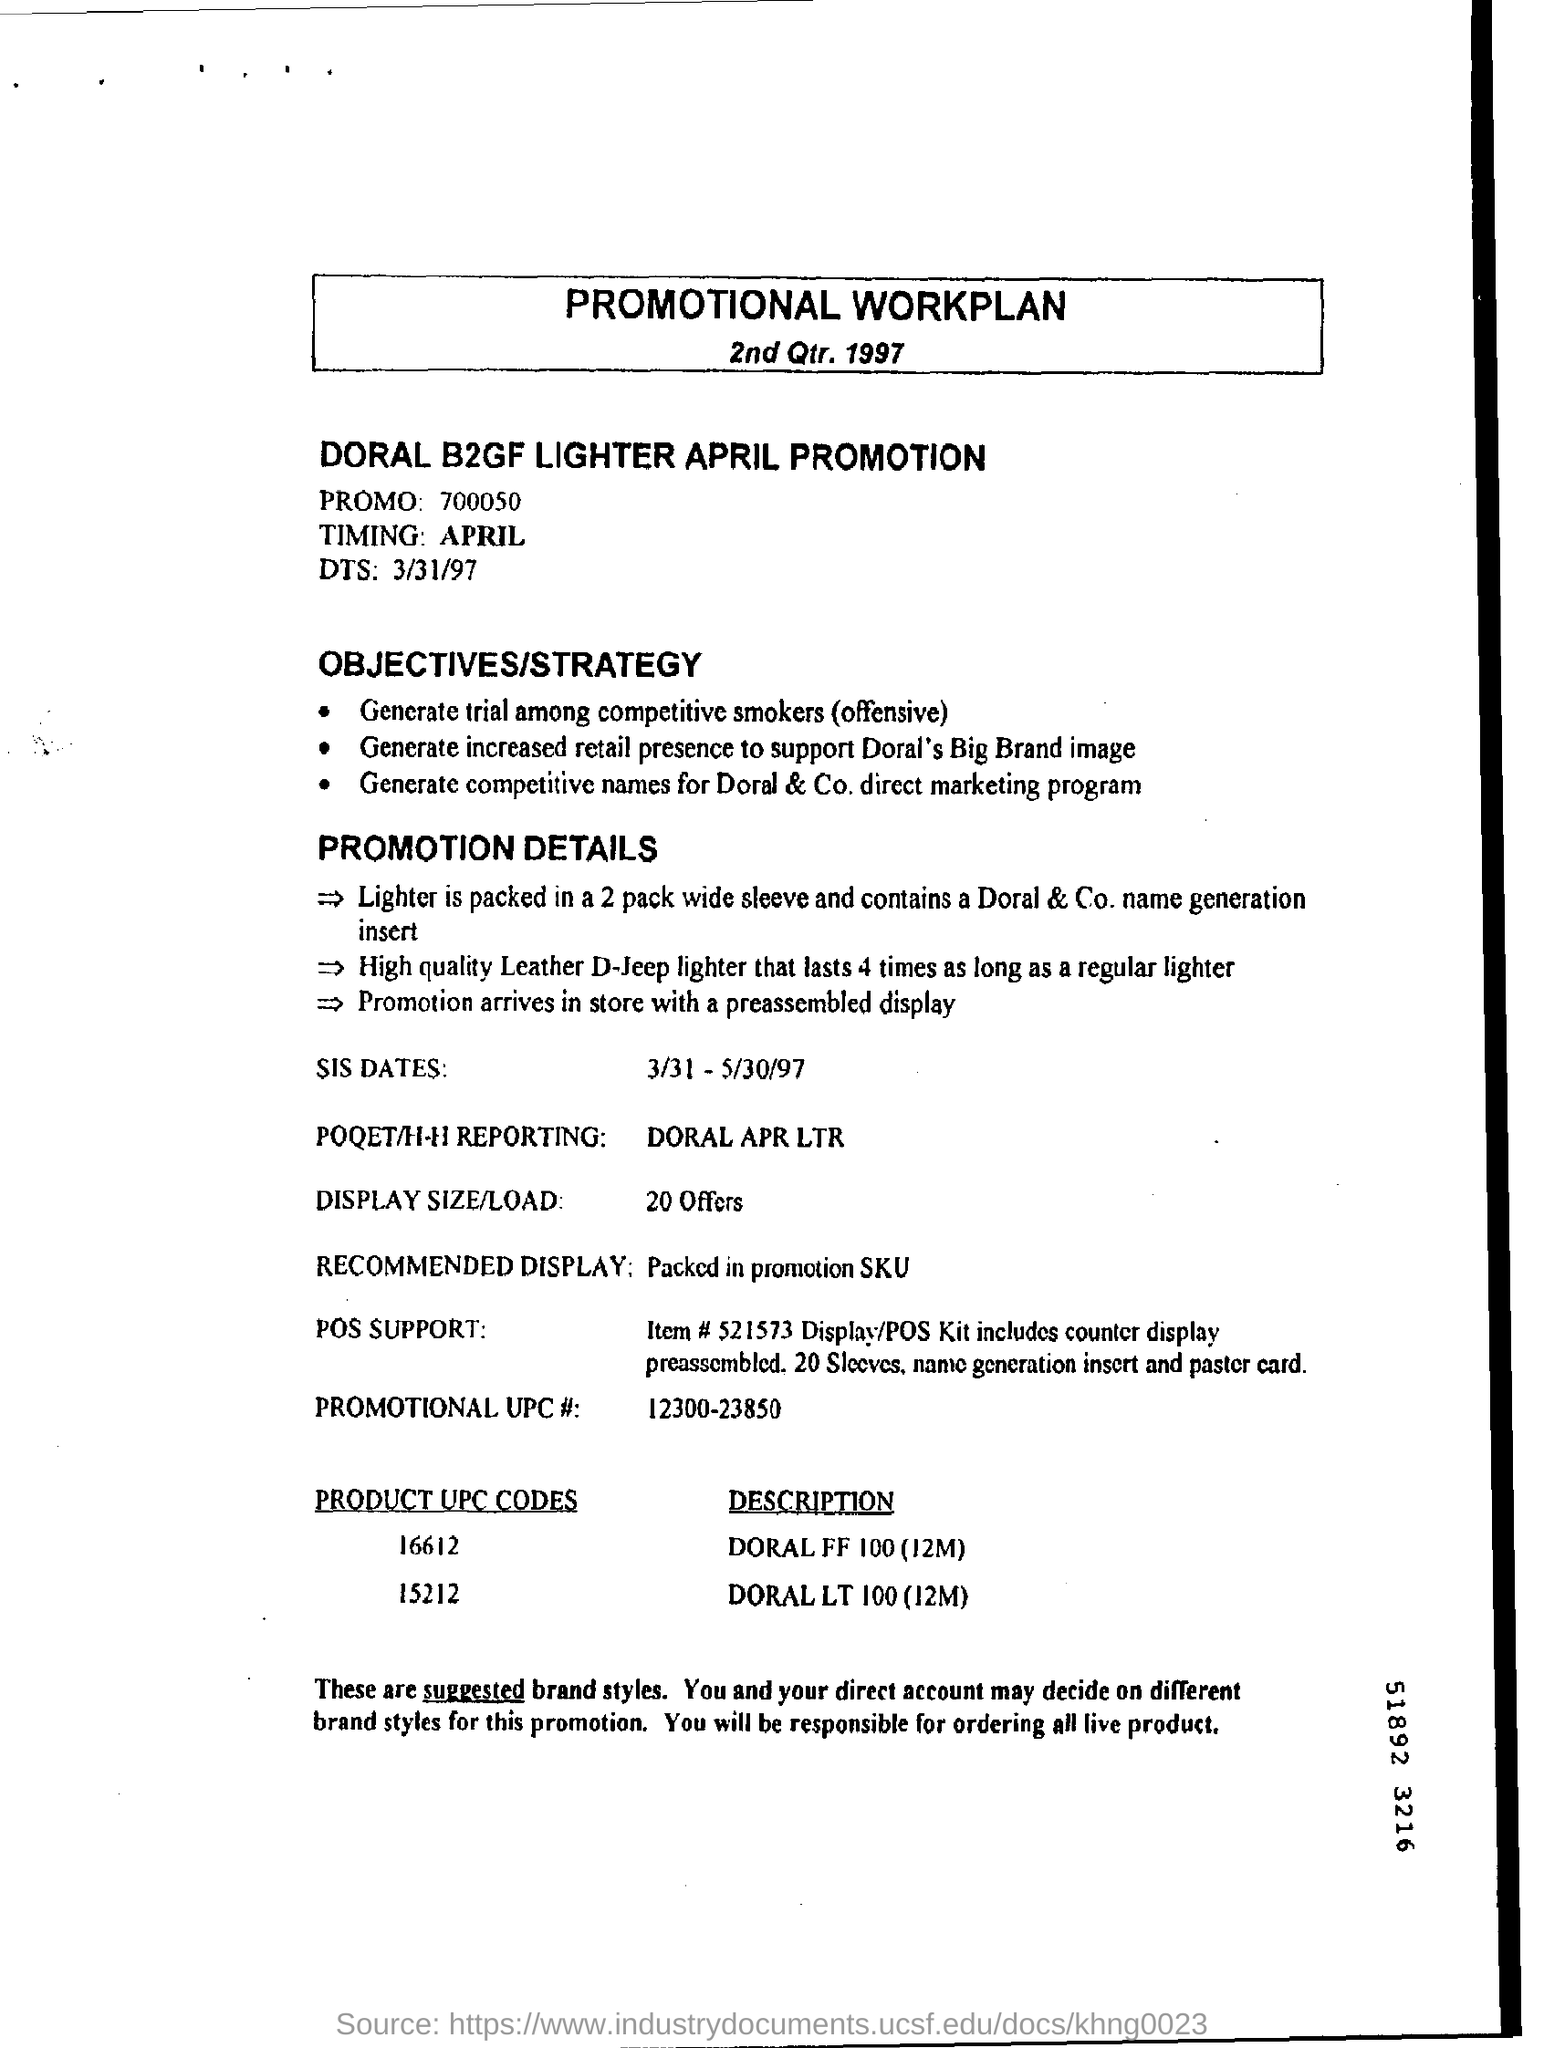What is the title of the document ?
Ensure brevity in your answer.  Promotional Workplan. What is promo number
Provide a short and direct response. 700050. What is "timing" mentioned?
Your answer should be compact. April. What is display size/load?
Offer a very short reply. 20 offers. 